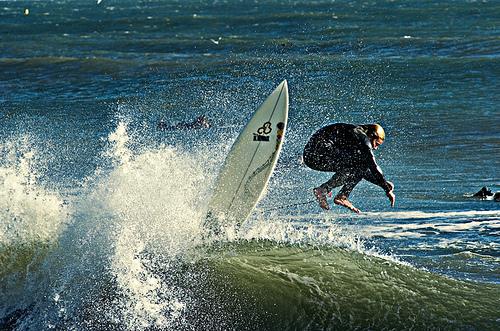Did he do this on purpose?
Short answer required. No. Did he hop off the wave?
Write a very short answer. Yes. Is he going to land on someone?
Give a very brief answer. No. 